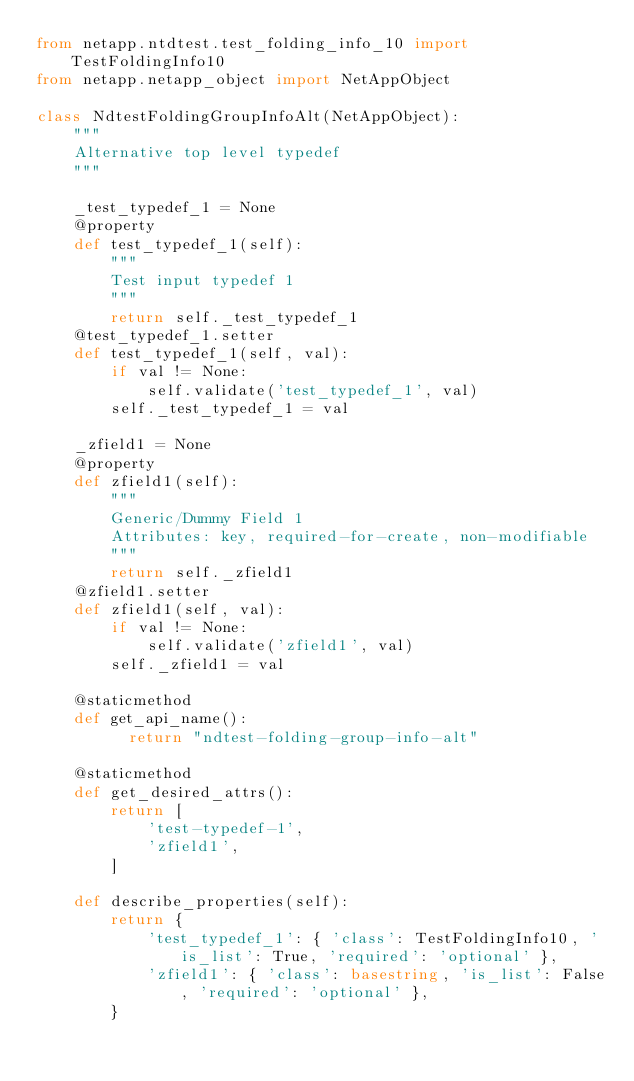Convert code to text. <code><loc_0><loc_0><loc_500><loc_500><_Python_>from netapp.ntdtest.test_folding_info_10 import TestFoldingInfo10
from netapp.netapp_object import NetAppObject

class NdtestFoldingGroupInfoAlt(NetAppObject):
    """
    Alternative top level typedef
    """
    
    _test_typedef_1 = None
    @property
    def test_typedef_1(self):
        """
        Test input typedef 1
        """
        return self._test_typedef_1
    @test_typedef_1.setter
    def test_typedef_1(self, val):
        if val != None:
            self.validate('test_typedef_1', val)
        self._test_typedef_1 = val
    
    _zfield1 = None
    @property
    def zfield1(self):
        """
        Generic/Dummy Field 1
        Attributes: key, required-for-create, non-modifiable
        """
        return self._zfield1
    @zfield1.setter
    def zfield1(self, val):
        if val != None:
            self.validate('zfield1', val)
        self._zfield1 = val
    
    @staticmethod
    def get_api_name():
          return "ndtest-folding-group-info-alt"
    
    @staticmethod
    def get_desired_attrs():
        return [
            'test-typedef-1',
            'zfield1',
        ]
    
    def describe_properties(self):
        return {
            'test_typedef_1': { 'class': TestFoldingInfo10, 'is_list': True, 'required': 'optional' },
            'zfield1': { 'class': basestring, 'is_list': False, 'required': 'optional' },
        }
</code> 